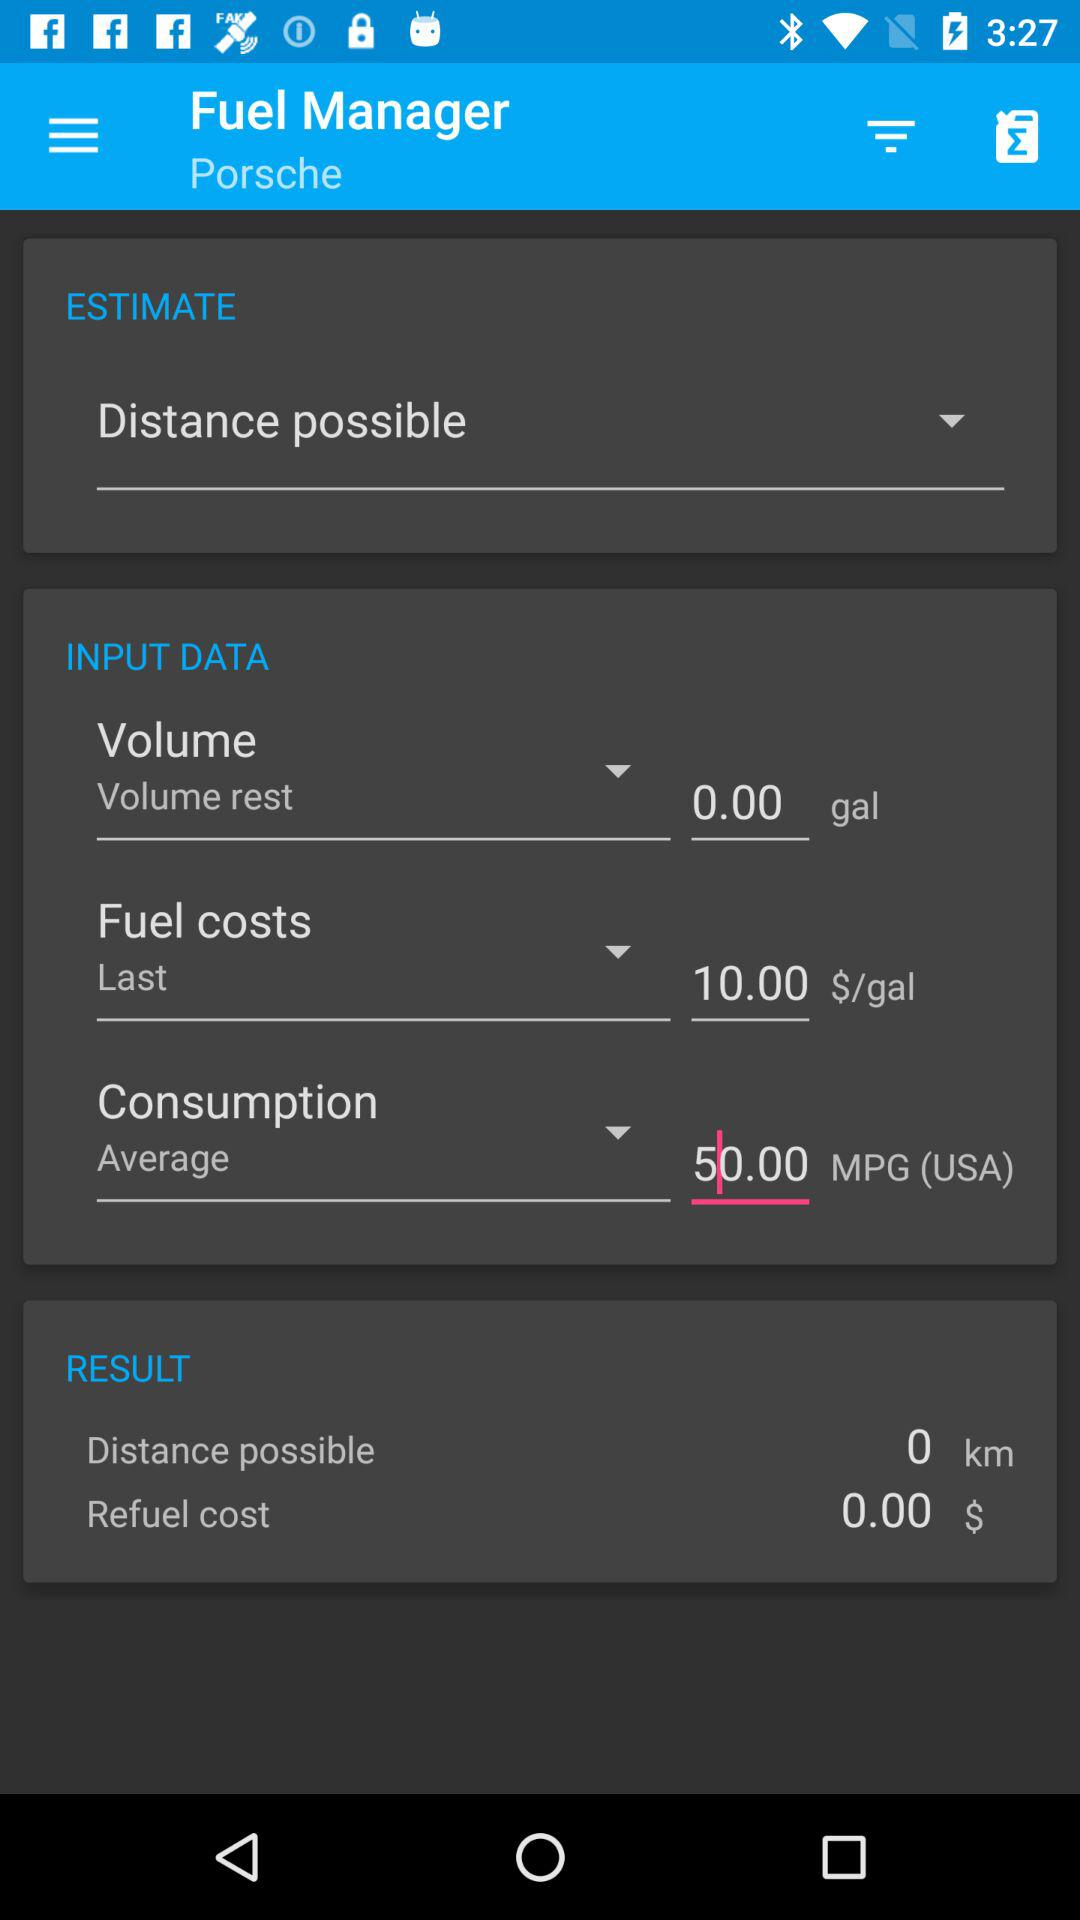How much fuel is consumed? The consumed fuel is 50.00 MPG. 